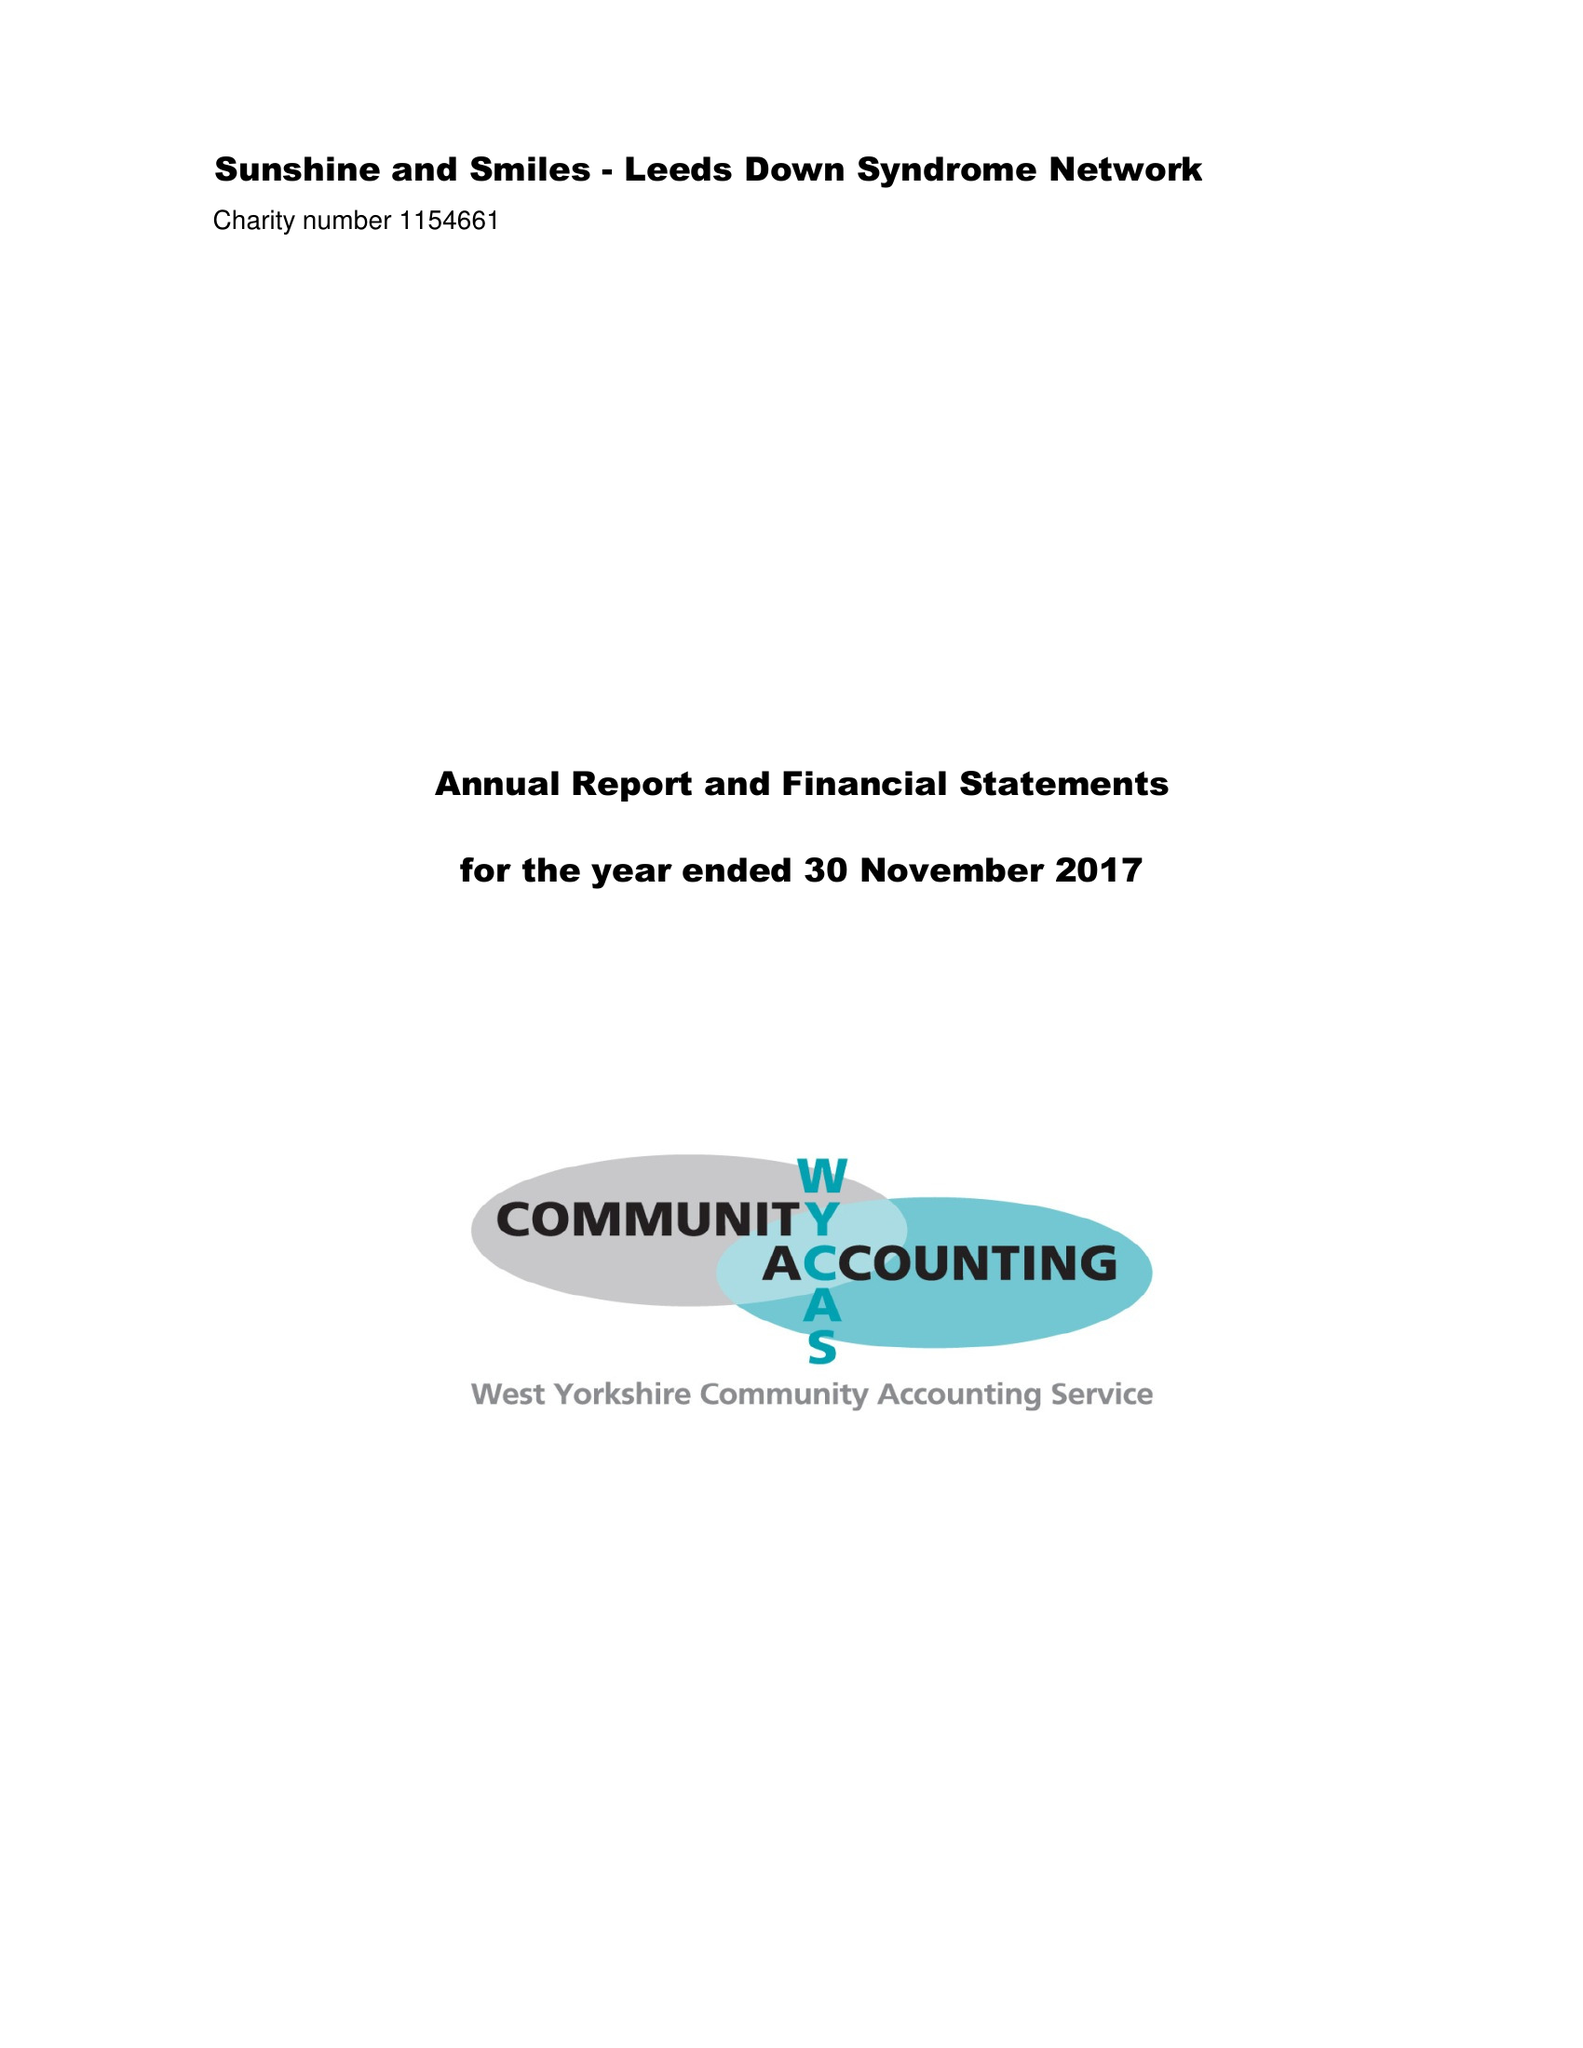What is the value for the spending_annually_in_british_pounds?
Answer the question using a single word or phrase. 55503.00 